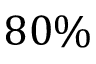<formula> <loc_0><loc_0><loc_500><loc_500>8 0 \%</formula> 